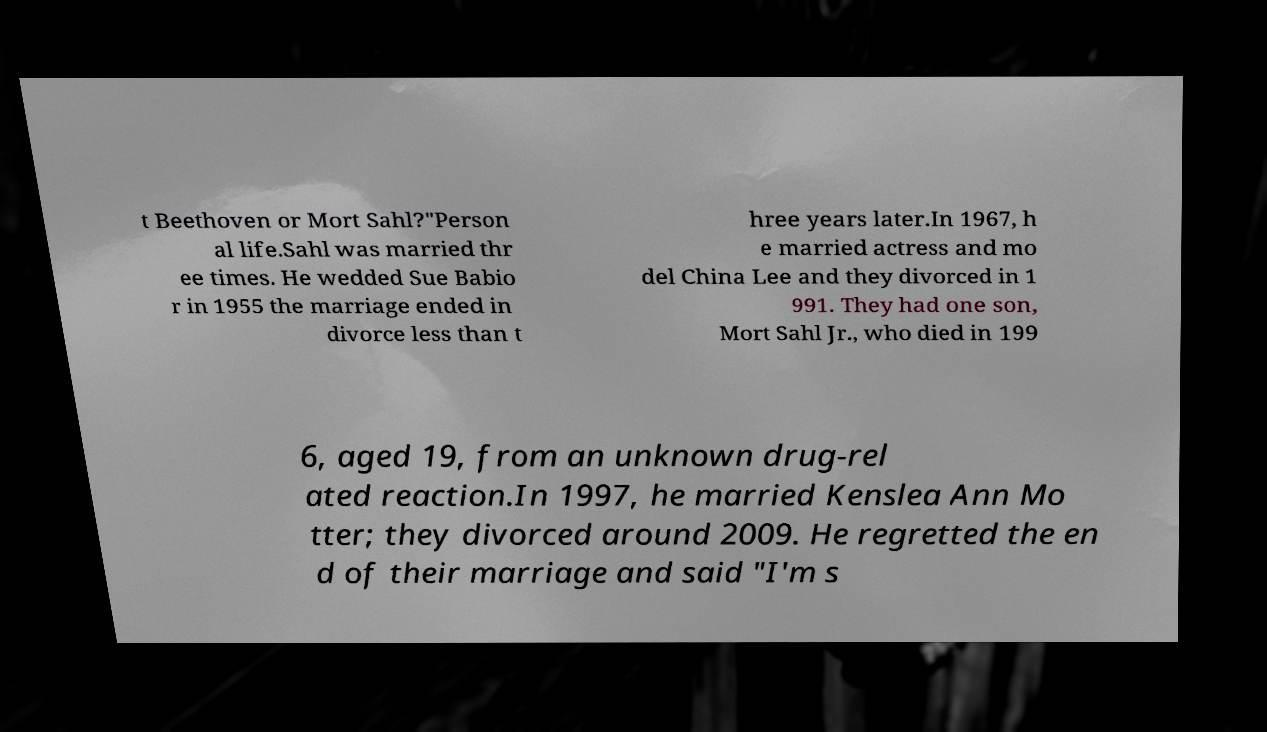Could you extract and type out the text from this image? t Beethoven or Mort Sahl?"Person al life.Sahl was married thr ee times. He wedded Sue Babio r in 1955 the marriage ended in divorce less than t hree years later.In 1967, h e married actress and mo del China Lee and they divorced in 1 991. They had one son, Mort Sahl Jr., who died in 199 6, aged 19, from an unknown drug-rel ated reaction.In 1997, he married Kenslea Ann Mo tter; they divorced around 2009. He regretted the en d of their marriage and said "I'm s 